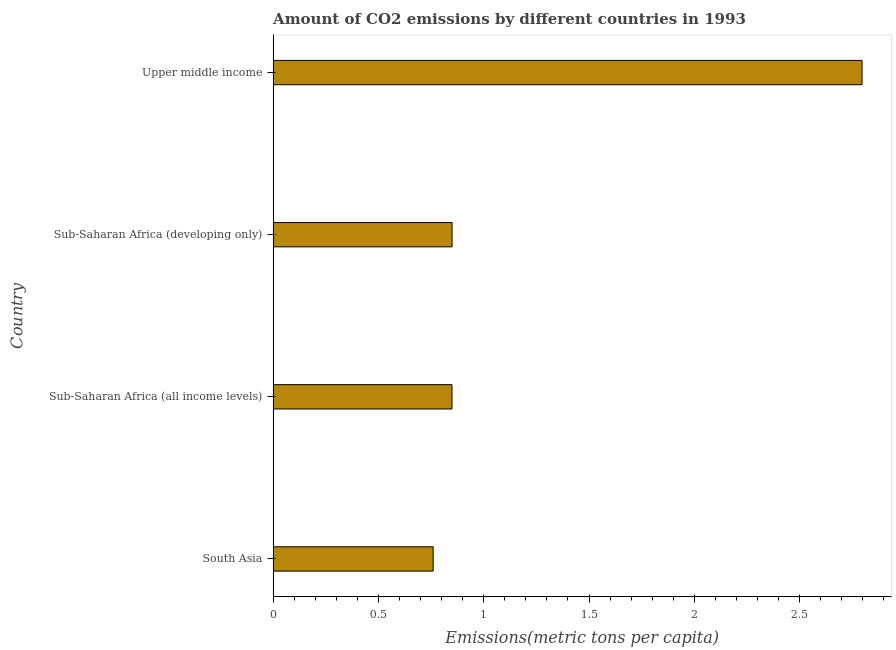What is the title of the graph?
Make the answer very short. Amount of CO2 emissions by different countries in 1993. What is the label or title of the X-axis?
Your answer should be very brief. Emissions(metric tons per capita). What is the label or title of the Y-axis?
Your answer should be compact. Country. What is the amount of co2 emissions in Sub-Saharan Africa (developing only)?
Provide a short and direct response. 0.85. Across all countries, what is the maximum amount of co2 emissions?
Keep it short and to the point. 2.8. Across all countries, what is the minimum amount of co2 emissions?
Your answer should be very brief. 0.76. In which country was the amount of co2 emissions maximum?
Your answer should be very brief. Upper middle income. In which country was the amount of co2 emissions minimum?
Give a very brief answer. South Asia. What is the sum of the amount of co2 emissions?
Your answer should be compact. 5.26. What is the difference between the amount of co2 emissions in South Asia and Sub-Saharan Africa (all income levels)?
Provide a succinct answer. -0.09. What is the average amount of co2 emissions per country?
Provide a succinct answer. 1.31. What is the median amount of co2 emissions?
Offer a terse response. 0.85. What is the ratio of the amount of co2 emissions in Sub-Saharan Africa (all income levels) to that in Upper middle income?
Give a very brief answer. 0.3. Is the amount of co2 emissions in Sub-Saharan Africa (all income levels) less than that in Upper middle income?
Your answer should be compact. Yes. Is the difference between the amount of co2 emissions in South Asia and Sub-Saharan Africa (all income levels) greater than the difference between any two countries?
Offer a terse response. No. What is the difference between the highest and the second highest amount of co2 emissions?
Offer a very short reply. 1.95. What is the difference between the highest and the lowest amount of co2 emissions?
Give a very brief answer. 2.04. In how many countries, is the amount of co2 emissions greater than the average amount of co2 emissions taken over all countries?
Provide a short and direct response. 1. Are all the bars in the graph horizontal?
Make the answer very short. Yes. Are the values on the major ticks of X-axis written in scientific E-notation?
Ensure brevity in your answer.  No. What is the Emissions(metric tons per capita) in South Asia?
Offer a terse response. 0.76. What is the Emissions(metric tons per capita) of Sub-Saharan Africa (all income levels)?
Provide a short and direct response. 0.85. What is the Emissions(metric tons per capita) in Sub-Saharan Africa (developing only)?
Provide a succinct answer. 0.85. What is the Emissions(metric tons per capita) of Upper middle income?
Keep it short and to the point. 2.8. What is the difference between the Emissions(metric tons per capita) in South Asia and Sub-Saharan Africa (all income levels)?
Ensure brevity in your answer.  -0.09. What is the difference between the Emissions(metric tons per capita) in South Asia and Sub-Saharan Africa (developing only)?
Ensure brevity in your answer.  -0.09. What is the difference between the Emissions(metric tons per capita) in South Asia and Upper middle income?
Your response must be concise. -2.04. What is the difference between the Emissions(metric tons per capita) in Sub-Saharan Africa (all income levels) and Sub-Saharan Africa (developing only)?
Your response must be concise. -0. What is the difference between the Emissions(metric tons per capita) in Sub-Saharan Africa (all income levels) and Upper middle income?
Your answer should be compact. -1.95. What is the difference between the Emissions(metric tons per capita) in Sub-Saharan Africa (developing only) and Upper middle income?
Provide a short and direct response. -1.95. What is the ratio of the Emissions(metric tons per capita) in South Asia to that in Sub-Saharan Africa (all income levels)?
Provide a succinct answer. 0.9. What is the ratio of the Emissions(metric tons per capita) in South Asia to that in Sub-Saharan Africa (developing only)?
Offer a very short reply. 0.89. What is the ratio of the Emissions(metric tons per capita) in South Asia to that in Upper middle income?
Give a very brief answer. 0.27. What is the ratio of the Emissions(metric tons per capita) in Sub-Saharan Africa (all income levels) to that in Upper middle income?
Make the answer very short. 0.3. What is the ratio of the Emissions(metric tons per capita) in Sub-Saharan Africa (developing only) to that in Upper middle income?
Keep it short and to the point. 0.3. 